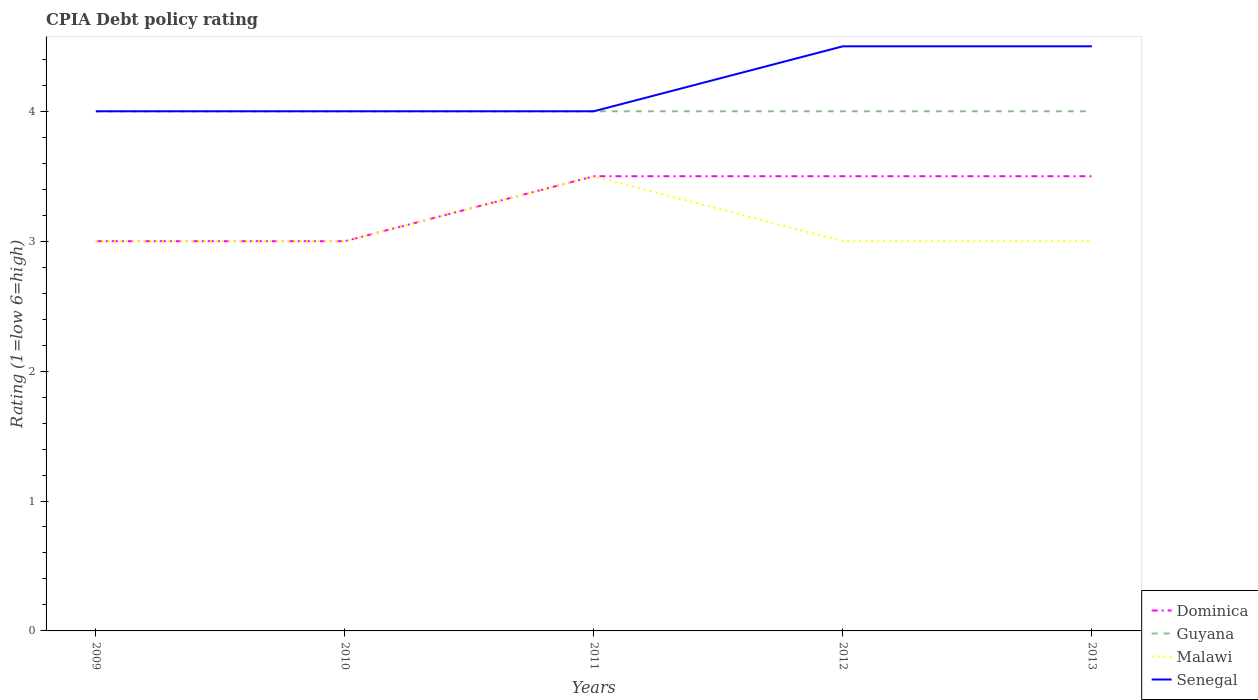Across all years, what is the maximum CPIA rating in Guyana?
Offer a very short reply. 4. In which year was the CPIA rating in Senegal maximum?
Offer a terse response. 2009. What is the total CPIA rating in Guyana in the graph?
Your answer should be compact. 0. What is the difference between the highest and the lowest CPIA rating in Dominica?
Provide a short and direct response. 3. How many lines are there?
Your answer should be compact. 4. What is the difference between two consecutive major ticks on the Y-axis?
Offer a very short reply. 1. Are the values on the major ticks of Y-axis written in scientific E-notation?
Your answer should be compact. No. Does the graph contain grids?
Your answer should be very brief. No. Where does the legend appear in the graph?
Make the answer very short. Bottom right. How many legend labels are there?
Offer a terse response. 4. What is the title of the graph?
Provide a short and direct response. CPIA Debt policy rating. What is the Rating (1=low 6=high) in Guyana in 2009?
Give a very brief answer. 4. What is the Rating (1=low 6=high) of Malawi in 2009?
Offer a very short reply. 3. What is the Rating (1=low 6=high) in Senegal in 2009?
Give a very brief answer. 4. What is the Rating (1=low 6=high) in Dominica in 2010?
Provide a succinct answer. 3. What is the Rating (1=low 6=high) of Guyana in 2010?
Offer a very short reply. 4. What is the Rating (1=low 6=high) in Senegal in 2010?
Your response must be concise. 4. What is the Rating (1=low 6=high) in Dominica in 2011?
Offer a terse response. 3.5. What is the Rating (1=low 6=high) in Malawi in 2011?
Ensure brevity in your answer.  3.5. What is the Rating (1=low 6=high) of Senegal in 2011?
Your answer should be very brief. 4. What is the Rating (1=low 6=high) in Dominica in 2012?
Your answer should be compact. 3.5. What is the Rating (1=low 6=high) in Guyana in 2012?
Offer a very short reply. 4. What is the Rating (1=low 6=high) in Senegal in 2012?
Give a very brief answer. 4.5. What is the Rating (1=low 6=high) of Dominica in 2013?
Keep it short and to the point. 3.5. What is the Rating (1=low 6=high) of Senegal in 2013?
Offer a terse response. 4.5. Across all years, what is the maximum Rating (1=low 6=high) of Dominica?
Your answer should be very brief. 3.5. Across all years, what is the maximum Rating (1=low 6=high) in Guyana?
Your answer should be compact. 4. Across all years, what is the maximum Rating (1=low 6=high) in Malawi?
Offer a terse response. 3.5. Across all years, what is the minimum Rating (1=low 6=high) in Dominica?
Offer a terse response. 3. Across all years, what is the minimum Rating (1=low 6=high) in Malawi?
Keep it short and to the point. 3. Across all years, what is the minimum Rating (1=low 6=high) of Senegal?
Provide a short and direct response. 4. What is the total Rating (1=low 6=high) of Dominica in the graph?
Provide a succinct answer. 16.5. What is the total Rating (1=low 6=high) of Senegal in the graph?
Make the answer very short. 21. What is the difference between the Rating (1=low 6=high) of Guyana in 2009 and that in 2010?
Provide a short and direct response. 0. What is the difference between the Rating (1=low 6=high) of Malawi in 2009 and that in 2010?
Give a very brief answer. 0. What is the difference between the Rating (1=low 6=high) of Dominica in 2009 and that in 2011?
Ensure brevity in your answer.  -0.5. What is the difference between the Rating (1=low 6=high) of Guyana in 2009 and that in 2011?
Your answer should be very brief. 0. What is the difference between the Rating (1=low 6=high) of Malawi in 2009 and that in 2011?
Your answer should be compact. -0.5. What is the difference between the Rating (1=low 6=high) in Senegal in 2009 and that in 2011?
Offer a terse response. 0. What is the difference between the Rating (1=low 6=high) of Dominica in 2009 and that in 2012?
Your answer should be compact. -0.5. What is the difference between the Rating (1=low 6=high) of Dominica in 2009 and that in 2013?
Keep it short and to the point. -0.5. What is the difference between the Rating (1=low 6=high) of Guyana in 2009 and that in 2013?
Your response must be concise. 0. What is the difference between the Rating (1=low 6=high) of Malawi in 2009 and that in 2013?
Your answer should be compact. 0. What is the difference between the Rating (1=low 6=high) in Senegal in 2009 and that in 2013?
Offer a terse response. -0.5. What is the difference between the Rating (1=low 6=high) in Dominica in 2010 and that in 2011?
Offer a terse response. -0.5. What is the difference between the Rating (1=low 6=high) in Senegal in 2010 and that in 2011?
Your answer should be compact. 0. What is the difference between the Rating (1=low 6=high) of Malawi in 2010 and that in 2012?
Offer a terse response. 0. What is the difference between the Rating (1=low 6=high) in Senegal in 2010 and that in 2012?
Ensure brevity in your answer.  -0.5. What is the difference between the Rating (1=low 6=high) of Guyana in 2010 and that in 2013?
Your answer should be very brief. 0. What is the difference between the Rating (1=low 6=high) of Malawi in 2011 and that in 2013?
Offer a very short reply. 0.5. What is the difference between the Rating (1=low 6=high) in Senegal in 2011 and that in 2013?
Ensure brevity in your answer.  -0.5. What is the difference between the Rating (1=low 6=high) in Dominica in 2012 and that in 2013?
Your answer should be very brief. 0. What is the difference between the Rating (1=low 6=high) in Guyana in 2012 and that in 2013?
Make the answer very short. 0. What is the difference between the Rating (1=low 6=high) in Dominica in 2009 and the Rating (1=low 6=high) in Guyana in 2010?
Offer a terse response. -1. What is the difference between the Rating (1=low 6=high) of Dominica in 2009 and the Rating (1=low 6=high) of Malawi in 2010?
Give a very brief answer. 0. What is the difference between the Rating (1=low 6=high) of Dominica in 2009 and the Rating (1=low 6=high) of Senegal in 2010?
Your response must be concise. -1. What is the difference between the Rating (1=low 6=high) in Guyana in 2009 and the Rating (1=low 6=high) in Malawi in 2010?
Offer a terse response. 1. What is the difference between the Rating (1=low 6=high) in Guyana in 2009 and the Rating (1=low 6=high) in Senegal in 2010?
Make the answer very short. 0. What is the difference between the Rating (1=low 6=high) in Malawi in 2009 and the Rating (1=low 6=high) in Senegal in 2010?
Your answer should be very brief. -1. What is the difference between the Rating (1=low 6=high) of Dominica in 2009 and the Rating (1=low 6=high) of Guyana in 2011?
Your response must be concise. -1. What is the difference between the Rating (1=low 6=high) of Guyana in 2009 and the Rating (1=low 6=high) of Malawi in 2011?
Provide a succinct answer. 0.5. What is the difference between the Rating (1=low 6=high) in Guyana in 2009 and the Rating (1=low 6=high) in Senegal in 2011?
Make the answer very short. 0. What is the difference between the Rating (1=low 6=high) in Dominica in 2009 and the Rating (1=low 6=high) in Guyana in 2012?
Offer a very short reply. -1. What is the difference between the Rating (1=low 6=high) in Dominica in 2009 and the Rating (1=low 6=high) in Senegal in 2012?
Give a very brief answer. -1.5. What is the difference between the Rating (1=low 6=high) of Malawi in 2009 and the Rating (1=low 6=high) of Senegal in 2012?
Offer a terse response. -1.5. What is the difference between the Rating (1=low 6=high) in Dominica in 2009 and the Rating (1=low 6=high) in Guyana in 2013?
Your answer should be very brief. -1. What is the difference between the Rating (1=low 6=high) of Guyana in 2009 and the Rating (1=low 6=high) of Malawi in 2013?
Make the answer very short. 1. What is the difference between the Rating (1=low 6=high) in Guyana in 2009 and the Rating (1=low 6=high) in Senegal in 2013?
Give a very brief answer. -0.5. What is the difference between the Rating (1=low 6=high) of Dominica in 2010 and the Rating (1=low 6=high) of Senegal in 2011?
Keep it short and to the point. -1. What is the difference between the Rating (1=low 6=high) in Guyana in 2010 and the Rating (1=low 6=high) in Malawi in 2011?
Your answer should be compact. 0.5. What is the difference between the Rating (1=low 6=high) of Guyana in 2010 and the Rating (1=low 6=high) of Malawi in 2012?
Make the answer very short. 1. What is the difference between the Rating (1=low 6=high) of Dominica in 2010 and the Rating (1=low 6=high) of Malawi in 2013?
Give a very brief answer. 0. What is the difference between the Rating (1=low 6=high) of Dominica in 2010 and the Rating (1=low 6=high) of Senegal in 2013?
Offer a terse response. -1.5. What is the difference between the Rating (1=low 6=high) in Guyana in 2010 and the Rating (1=low 6=high) in Malawi in 2013?
Offer a terse response. 1. What is the difference between the Rating (1=low 6=high) in Guyana in 2010 and the Rating (1=low 6=high) in Senegal in 2013?
Your answer should be compact. -0.5. What is the difference between the Rating (1=low 6=high) of Malawi in 2010 and the Rating (1=low 6=high) of Senegal in 2013?
Provide a succinct answer. -1.5. What is the difference between the Rating (1=low 6=high) of Dominica in 2011 and the Rating (1=low 6=high) of Guyana in 2012?
Provide a succinct answer. -0.5. What is the difference between the Rating (1=low 6=high) of Dominica in 2011 and the Rating (1=low 6=high) of Senegal in 2012?
Provide a short and direct response. -1. What is the difference between the Rating (1=low 6=high) of Guyana in 2011 and the Rating (1=low 6=high) of Malawi in 2012?
Give a very brief answer. 1. What is the difference between the Rating (1=low 6=high) in Guyana in 2011 and the Rating (1=low 6=high) in Senegal in 2012?
Ensure brevity in your answer.  -0.5. What is the difference between the Rating (1=low 6=high) of Malawi in 2011 and the Rating (1=low 6=high) of Senegal in 2012?
Keep it short and to the point. -1. What is the difference between the Rating (1=low 6=high) of Dominica in 2011 and the Rating (1=low 6=high) of Guyana in 2013?
Offer a very short reply. -0.5. What is the difference between the Rating (1=low 6=high) of Dominica in 2011 and the Rating (1=low 6=high) of Senegal in 2013?
Your answer should be very brief. -1. What is the difference between the Rating (1=low 6=high) in Guyana in 2011 and the Rating (1=low 6=high) in Malawi in 2013?
Your answer should be compact. 1. What is the difference between the Rating (1=low 6=high) of Dominica in 2012 and the Rating (1=low 6=high) of Guyana in 2013?
Offer a terse response. -0.5. What is the difference between the Rating (1=low 6=high) of Dominica in 2012 and the Rating (1=low 6=high) of Senegal in 2013?
Make the answer very short. -1. What is the average Rating (1=low 6=high) in Dominica per year?
Your answer should be very brief. 3.3. What is the average Rating (1=low 6=high) of Guyana per year?
Your answer should be compact. 4. What is the average Rating (1=low 6=high) in Malawi per year?
Offer a terse response. 3.1. What is the average Rating (1=low 6=high) of Senegal per year?
Offer a terse response. 4.2. In the year 2009, what is the difference between the Rating (1=low 6=high) in Dominica and Rating (1=low 6=high) in Guyana?
Offer a terse response. -1. In the year 2009, what is the difference between the Rating (1=low 6=high) of Dominica and Rating (1=low 6=high) of Senegal?
Provide a succinct answer. -1. In the year 2009, what is the difference between the Rating (1=low 6=high) of Guyana and Rating (1=low 6=high) of Senegal?
Ensure brevity in your answer.  0. In the year 2009, what is the difference between the Rating (1=low 6=high) of Malawi and Rating (1=low 6=high) of Senegal?
Give a very brief answer. -1. In the year 2010, what is the difference between the Rating (1=low 6=high) of Dominica and Rating (1=low 6=high) of Guyana?
Your answer should be compact. -1. In the year 2010, what is the difference between the Rating (1=low 6=high) of Dominica and Rating (1=low 6=high) of Malawi?
Provide a short and direct response. 0. In the year 2010, what is the difference between the Rating (1=low 6=high) in Dominica and Rating (1=low 6=high) in Senegal?
Offer a very short reply. -1. In the year 2010, what is the difference between the Rating (1=low 6=high) in Guyana and Rating (1=low 6=high) in Malawi?
Provide a short and direct response. 1. In the year 2010, what is the difference between the Rating (1=low 6=high) in Guyana and Rating (1=low 6=high) in Senegal?
Your answer should be very brief. 0. In the year 2010, what is the difference between the Rating (1=low 6=high) in Malawi and Rating (1=low 6=high) in Senegal?
Ensure brevity in your answer.  -1. In the year 2011, what is the difference between the Rating (1=low 6=high) of Dominica and Rating (1=low 6=high) of Guyana?
Ensure brevity in your answer.  -0.5. In the year 2011, what is the difference between the Rating (1=low 6=high) in Dominica and Rating (1=low 6=high) in Malawi?
Keep it short and to the point. 0. In the year 2011, what is the difference between the Rating (1=low 6=high) in Guyana and Rating (1=low 6=high) in Malawi?
Ensure brevity in your answer.  0.5. In the year 2011, what is the difference between the Rating (1=low 6=high) in Guyana and Rating (1=low 6=high) in Senegal?
Ensure brevity in your answer.  0. In the year 2011, what is the difference between the Rating (1=low 6=high) of Malawi and Rating (1=low 6=high) of Senegal?
Keep it short and to the point. -0.5. In the year 2012, what is the difference between the Rating (1=low 6=high) of Dominica and Rating (1=low 6=high) of Malawi?
Give a very brief answer. 0.5. In the year 2012, what is the difference between the Rating (1=low 6=high) of Guyana and Rating (1=low 6=high) of Senegal?
Your answer should be compact. -0.5. In the year 2012, what is the difference between the Rating (1=low 6=high) in Malawi and Rating (1=low 6=high) in Senegal?
Ensure brevity in your answer.  -1.5. In the year 2013, what is the difference between the Rating (1=low 6=high) in Dominica and Rating (1=low 6=high) in Malawi?
Your answer should be very brief. 0.5. In the year 2013, what is the difference between the Rating (1=low 6=high) in Dominica and Rating (1=low 6=high) in Senegal?
Keep it short and to the point. -1. In the year 2013, what is the difference between the Rating (1=low 6=high) in Malawi and Rating (1=low 6=high) in Senegal?
Ensure brevity in your answer.  -1.5. What is the ratio of the Rating (1=low 6=high) of Guyana in 2009 to that in 2010?
Provide a succinct answer. 1. What is the ratio of the Rating (1=low 6=high) in Malawi in 2009 to that in 2010?
Ensure brevity in your answer.  1. What is the ratio of the Rating (1=low 6=high) in Senegal in 2009 to that in 2010?
Make the answer very short. 1. What is the ratio of the Rating (1=low 6=high) of Senegal in 2009 to that in 2011?
Make the answer very short. 1. What is the ratio of the Rating (1=low 6=high) of Senegal in 2009 to that in 2012?
Provide a short and direct response. 0.89. What is the ratio of the Rating (1=low 6=high) of Dominica in 2009 to that in 2013?
Offer a terse response. 0.86. What is the ratio of the Rating (1=low 6=high) of Senegal in 2009 to that in 2013?
Give a very brief answer. 0.89. What is the ratio of the Rating (1=low 6=high) of Dominica in 2010 to that in 2011?
Ensure brevity in your answer.  0.86. What is the ratio of the Rating (1=low 6=high) of Guyana in 2010 to that in 2011?
Keep it short and to the point. 1. What is the ratio of the Rating (1=low 6=high) of Malawi in 2010 to that in 2011?
Keep it short and to the point. 0.86. What is the ratio of the Rating (1=low 6=high) of Senegal in 2010 to that in 2011?
Give a very brief answer. 1. What is the ratio of the Rating (1=low 6=high) of Dominica in 2010 to that in 2012?
Offer a terse response. 0.86. What is the ratio of the Rating (1=low 6=high) of Dominica in 2010 to that in 2013?
Give a very brief answer. 0.86. What is the ratio of the Rating (1=low 6=high) in Guyana in 2010 to that in 2013?
Make the answer very short. 1. What is the ratio of the Rating (1=low 6=high) in Dominica in 2011 to that in 2012?
Provide a succinct answer. 1. What is the ratio of the Rating (1=low 6=high) of Malawi in 2011 to that in 2012?
Make the answer very short. 1.17. What is the ratio of the Rating (1=low 6=high) of Dominica in 2011 to that in 2013?
Keep it short and to the point. 1. What is the ratio of the Rating (1=low 6=high) of Guyana in 2011 to that in 2013?
Give a very brief answer. 1. What is the ratio of the Rating (1=low 6=high) in Senegal in 2011 to that in 2013?
Your answer should be compact. 0.89. What is the ratio of the Rating (1=low 6=high) of Dominica in 2012 to that in 2013?
Offer a terse response. 1. What is the ratio of the Rating (1=low 6=high) in Malawi in 2012 to that in 2013?
Your answer should be compact. 1. What is the ratio of the Rating (1=low 6=high) in Senegal in 2012 to that in 2013?
Make the answer very short. 1. What is the difference between the highest and the lowest Rating (1=low 6=high) in Guyana?
Provide a short and direct response. 0. What is the difference between the highest and the lowest Rating (1=low 6=high) in Malawi?
Provide a short and direct response. 0.5. What is the difference between the highest and the lowest Rating (1=low 6=high) of Senegal?
Offer a terse response. 0.5. 